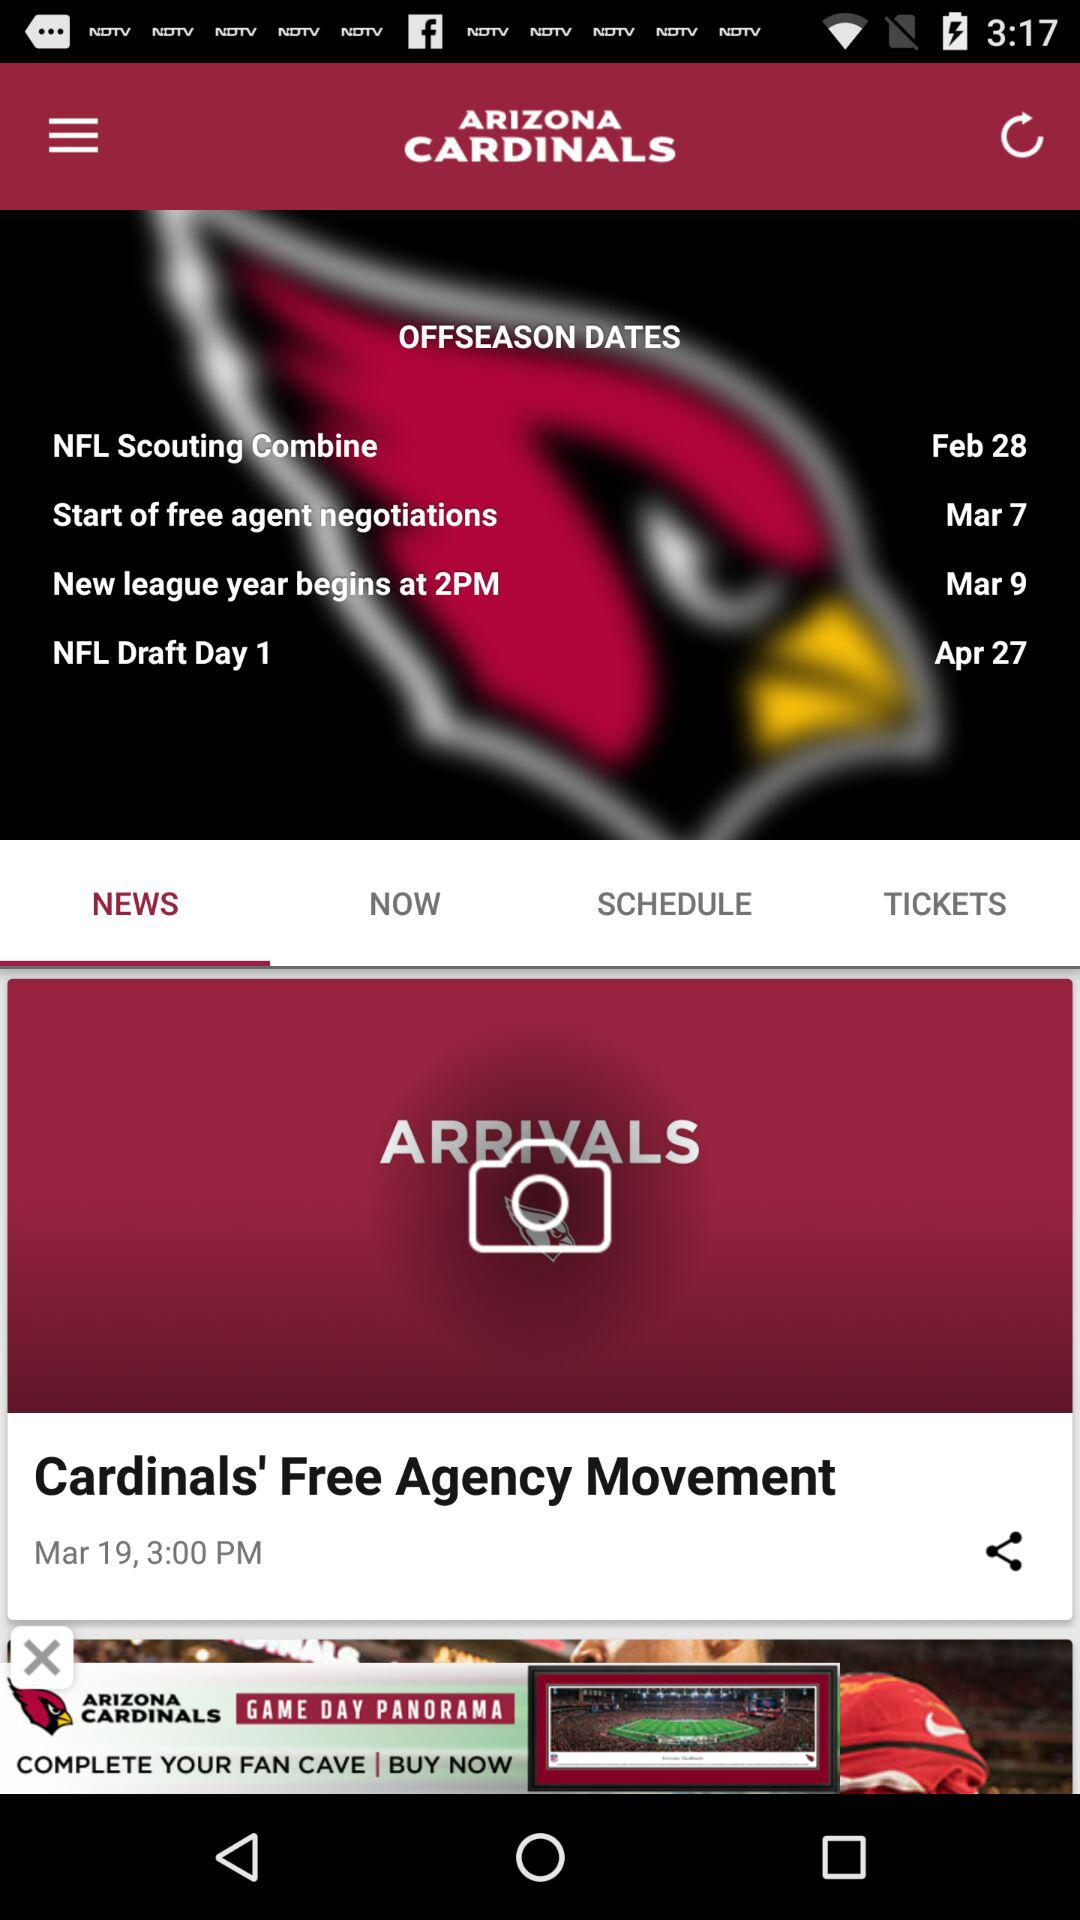How many more offseason dates are there than arrivals?
Answer the question using a single word or phrase. 3 